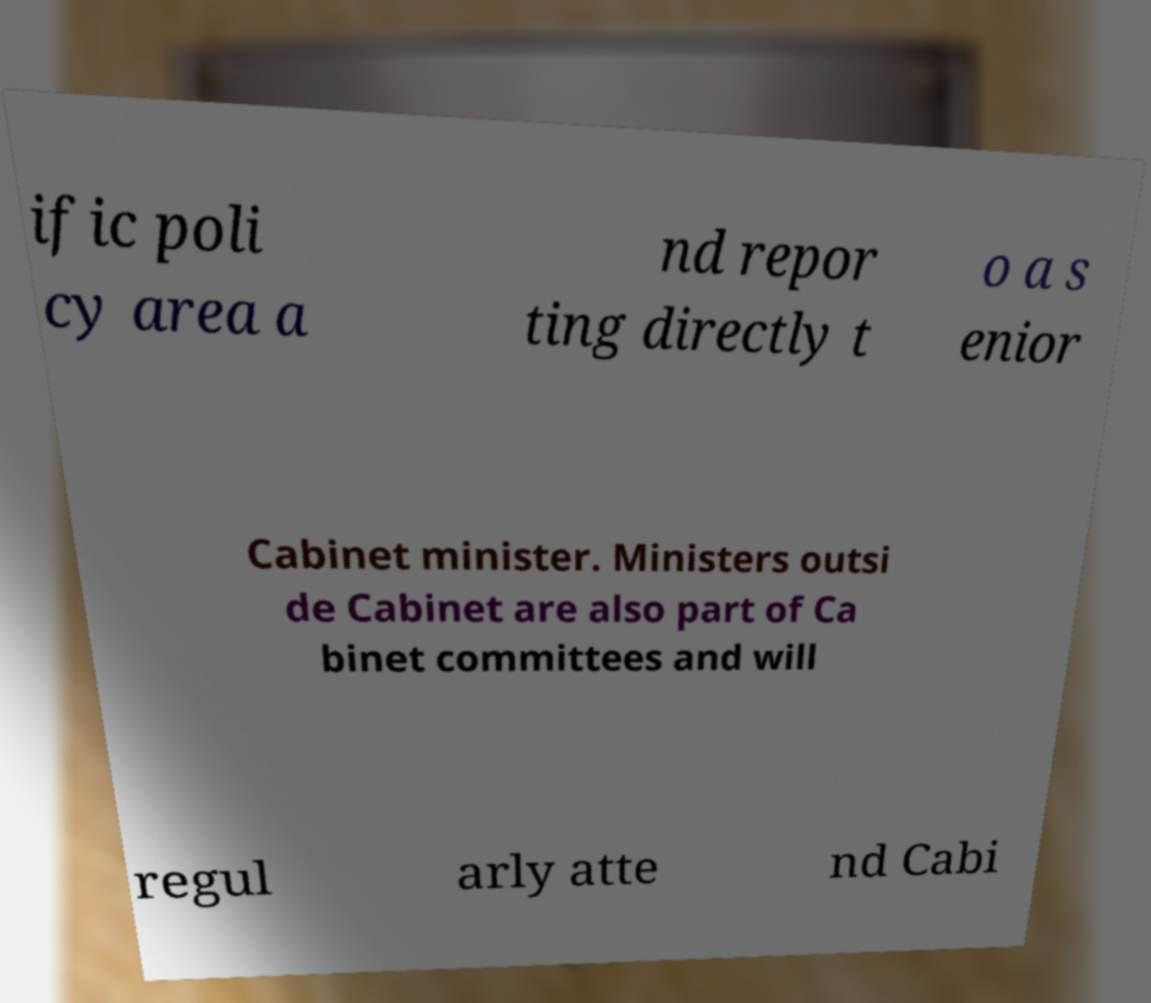Could you extract and type out the text from this image? ific poli cy area a nd repor ting directly t o a s enior Cabinet minister. Ministers outsi de Cabinet are also part of Ca binet committees and will regul arly atte nd Cabi 